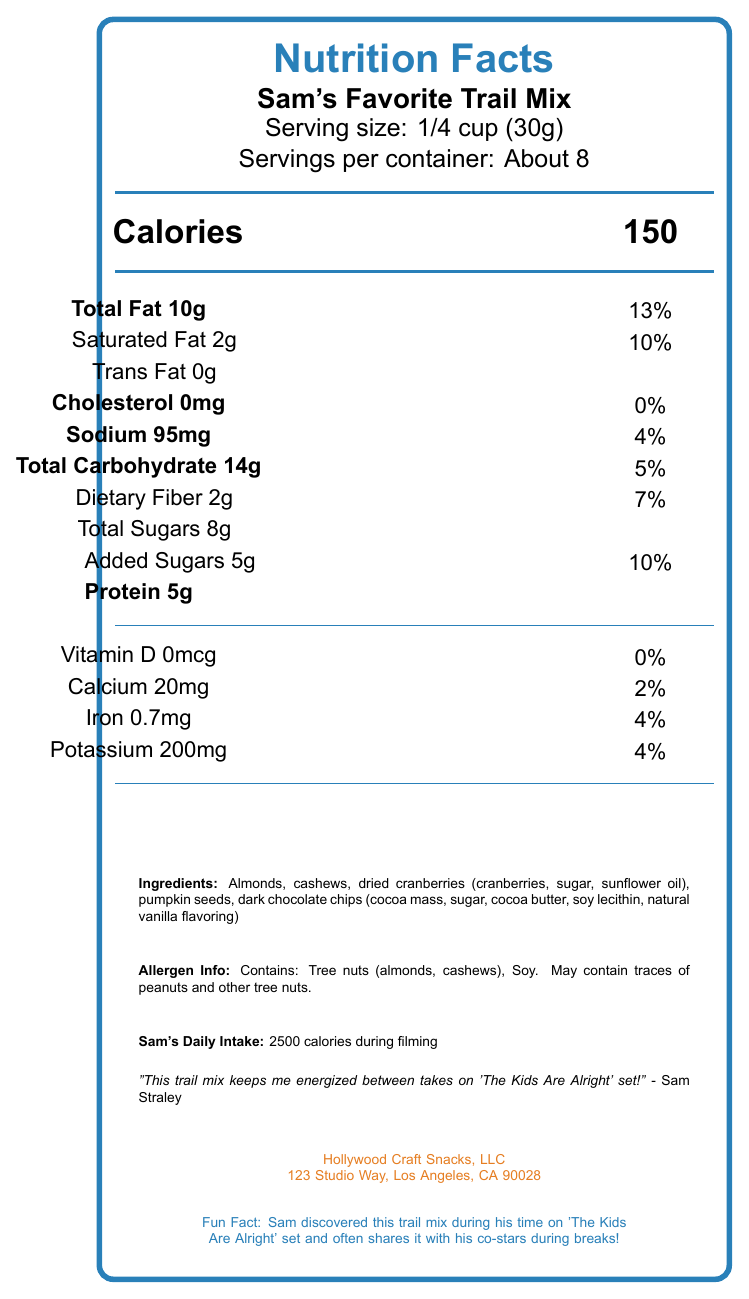what is the serving size for Sam's Favorite Trail Mix? The serving size is listed at the top of the Nutrition Facts label under "Serving size."
Answer: 1/4 cup (30g) how many calories are there per serving in Sam's Favorite Trail Mix? The calories per serving are shown prominently in the middle of the Nutrition Facts label.
Answer: 150 how many grams of protein are in one serving? The amount of protein per serving is listed under the nutritional information as "Protein 5g."
Answer: 5g what is the address of the manufacturer of Sam's Favorite Trail Mix? The address is listed at the bottom of the document under "Hollywood Craft Snacks, LLC."
Answer: 123 Studio Way, Los Angeles, CA 90028 what percentage of daily value of sodium is in one serving of Sam's Favorite Trail Mix? The daily value percentage for sodium is listed next to "Sodium 95mg" under the nutritional details.
Answer: 4% what ingredient contains allergens in Sam's Favorite Trail Mix? A. Dried cranberries B. Pumpkin seeds C. Almonds The allergen information mentions "Tree nuts (almonds, cashews)," with almonds being one of them.
Answer: C how many times does Sam Straley eat this trail mix per day during filming? Sam's snack frequency is noted under "Sam's Daily Intake" as "3 times per day."
Answer: 3 times per day which nutrient has the highest daily value percentage per serving? A. Total Fat B. Dietary Fiber C. Calcium Total Fat has the highest daily value percentage at 13%.
Answer: A does Sam's Favorite Trail Mix contain trans fat? The label shows "Trans Fat 0g" indicating there are no trans fats in the trail mix.
Answer: No is there any Vitamin D in the trail mix? The nutritional information shows "Vitamin D 0mcg" with a daily value of "0%."
Answer: No what is Sam Straley's favorite quote about this trail mix? The quote is listed under "Sam's Daily Intake" towards the bottom of the document.
Answer: "This trail mix keeps me energized between takes on 'The Kids Are Alright' set!" - Sam Straley how many servings are in one container of Sam's Favorite Trail Mix? The number of servings per container is noted under "Servings per container."
Answer: About 8 please summarize the main idea of this document. The summary covers the key aspects of the document, including nutritional details, Sam Straley's preferences, and the manufacturer information.
Answer: The document is a Nutrition Facts label for Sam's Favorite Trail Mix, detailing its nutritional content, ingredients, allergen information, Sam Straley's daily intake and quote, and fun facts about his discovery of the snack during filming. how many calories does Sam Straley consume in total from this trail mix if he has it 3 times a day? Sam consumes 150 calories per serving and has the snack 3 times a day. 150 x 3 = 450 calories.
Answer: 450 calories what is Sam Straley's favorite fun fact about the trail mix? The document lists fun facts but does not specify which one is Sam Straley's favorite.
Answer: Cannot be determined what ingredient is not a tree nut? A. Almonds B. Cashews C. Pumpkin seeds Pumpkin seeds are not considered tree nuts.
Answer: C 